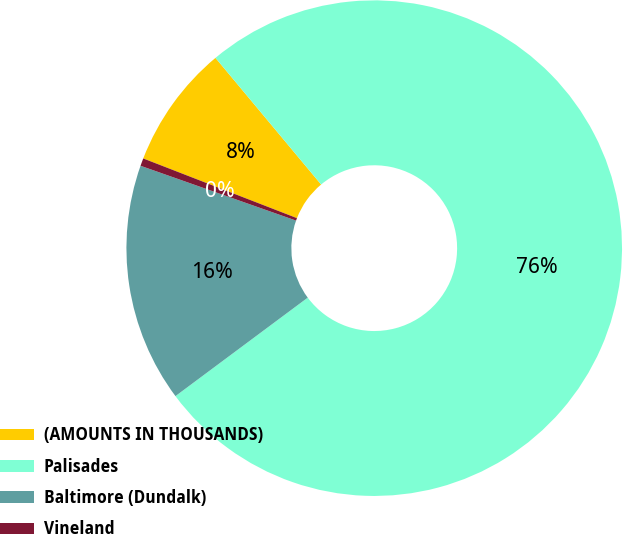<chart> <loc_0><loc_0><loc_500><loc_500><pie_chart><fcel>(AMOUNTS IN THOUSANDS)<fcel>Palisades<fcel>Baltimore (Dundalk)<fcel>Vineland<nl><fcel>8.04%<fcel>75.89%<fcel>15.58%<fcel>0.5%<nl></chart> 